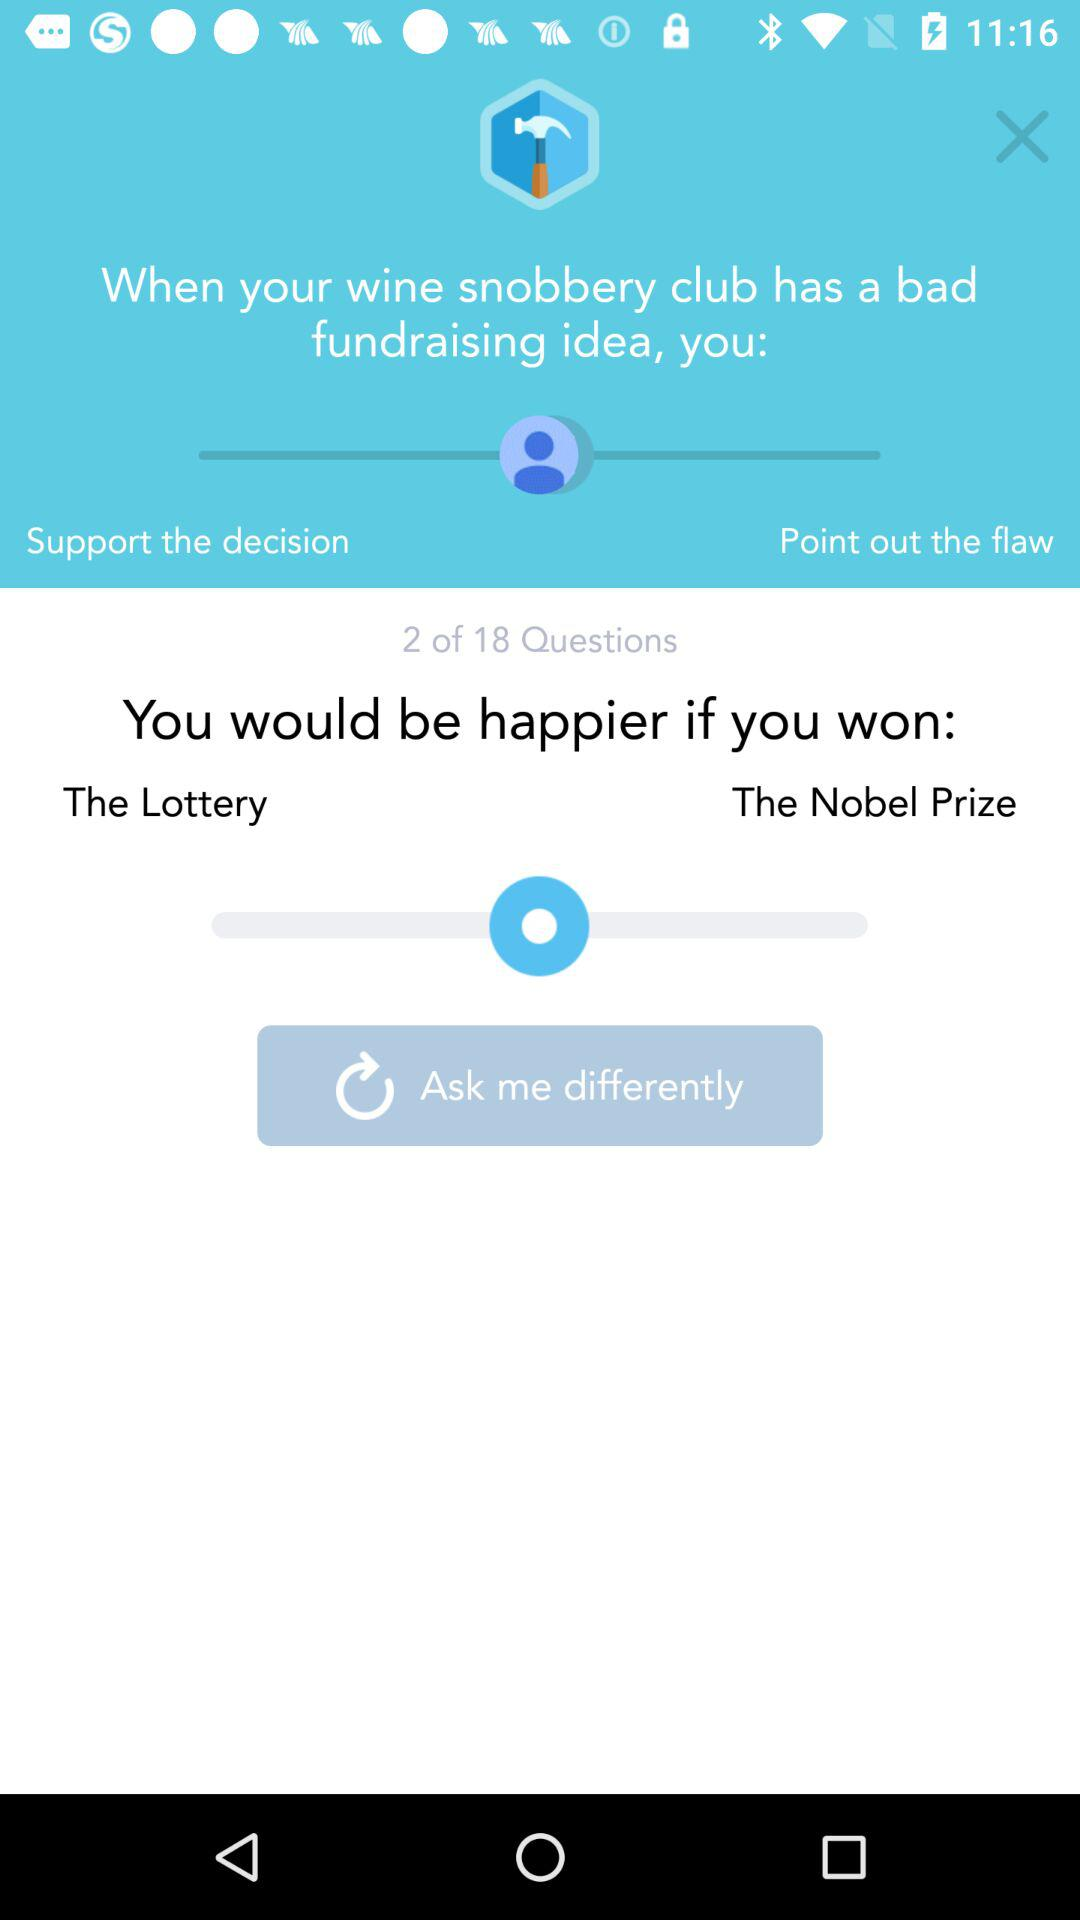How many questions in total are there? There are 18 questions in total. 